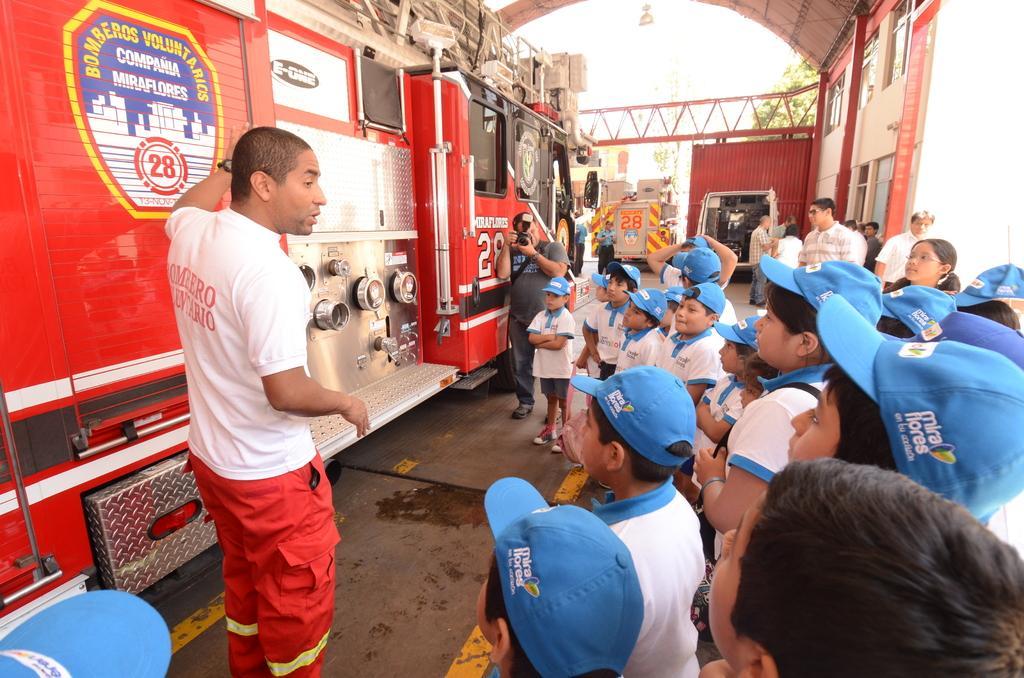Please provide a concise description of this image. There are group of children standing. This looks like a truck, which is red in color. I can see a person standing and holding a camera. There are few people standing. This looks like a building with the windows. I can see two vehicles, which are parked. 